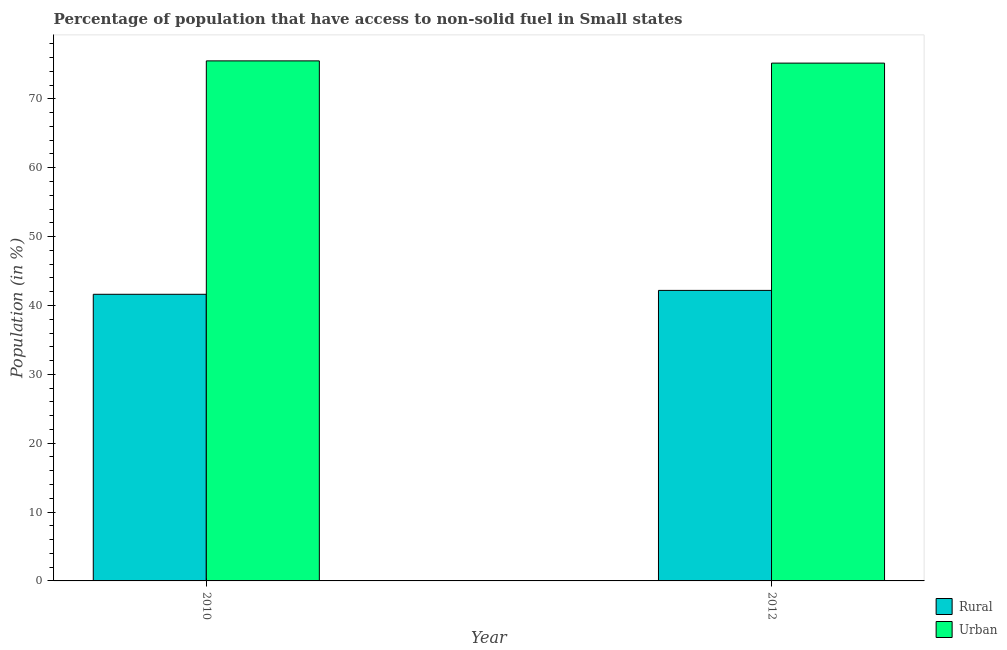How many different coloured bars are there?
Ensure brevity in your answer.  2. How many groups of bars are there?
Your response must be concise. 2. Are the number of bars on each tick of the X-axis equal?
Offer a very short reply. Yes. How many bars are there on the 2nd tick from the right?
Provide a succinct answer. 2. What is the label of the 2nd group of bars from the left?
Give a very brief answer. 2012. What is the rural population in 2010?
Your response must be concise. 41.62. Across all years, what is the maximum urban population?
Offer a very short reply. 75.52. Across all years, what is the minimum rural population?
Make the answer very short. 41.62. In which year was the rural population maximum?
Offer a terse response. 2012. In which year was the urban population minimum?
Provide a succinct answer. 2012. What is the total urban population in the graph?
Your answer should be compact. 150.72. What is the difference between the rural population in 2010 and that in 2012?
Give a very brief answer. -0.56. What is the difference between the urban population in 2012 and the rural population in 2010?
Make the answer very short. -0.33. What is the average rural population per year?
Make the answer very short. 41.91. What is the ratio of the urban population in 2010 to that in 2012?
Offer a terse response. 1. Is the urban population in 2010 less than that in 2012?
Make the answer very short. No. What does the 2nd bar from the left in 2012 represents?
Give a very brief answer. Urban. What does the 2nd bar from the right in 2012 represents?
Provide a succinct answer. Rural. Are all the bars in the graph horizontal?
Keep it short and to the point. No. How many years are there in the graph?
Make the answer very short. 2. Are the values on the major ticks of Y-axis written in scientific E-notation?
Ensure brevity in your answer.  No. Where does the legend appear in the graph?
Your response must be concise. Bottom right. How are the legend labels stacked?
Your answer should be compact. Vertical. What is the title of the graph?
Provide a short and direct response. Percentage of population that have access to non-solid fuel in Small states. Does "Forest land" appear as one of the legend labels in the graph?
Provide a short and direct response. No. What is the label or title of the X-axis?
Provide a succinct answer. Year. What is the Population (in %) in Rural in 2010?
Offer a very short reply. 41.62. What is the Population (in %) of Urban in 2010?
Your answer should be very brief. 75.52. What is the Population (in %) of Rural in 2012?
Ensure brevity in your answer.  42.19. What is the Population (in %) of Urban in 2012?
Offer a very short reply. 75.19. Across all years, what is the maximum Population (in %) in Rural?
Give a very brief answer. 42.19. Across all years, what is the maximum Population (in %) in Urban?
Your response must be concise. 75.52. Across all years, what is the minimum Population (in %) of Rural?
Offer a very short reply. 41.62. Across all years, what is the minimum Population (in %) of Urban?
Ensure brevity in your answer.  75.19. What is the total Population (in %) in Rural in the graph?
Your response must be concise. 83.81. What is the total Population (in %) in Urban in the graph?
Your answer should be compact. 150.72. What is the difference between the Population (in %) in Rural in 2010 and that in 2012?
Give a very brief answer. -0.56. What is the difference between the Population (in %) in Urban in 2010 and that in 2012?
Provide a short and direct response. 0.33. What is the difference between the Population (in %) of Rural in 2010 and the Population (in %) of Urban in 2012?
Keep it short and to the point. -33.57. What is the average Population (in %) in Rural per year?
Make the answer very short. 41.91. What is the average Population (in %) in Urban per year?
Your answer should be compact. 75.36. In the year 2010, what is the difference between the Population (in %) in Rural and Population (in %) in Urban?
Make the answer very short. -33.9. In the year 2012, what is the difference between the Population (in %) in Rural and Population (in %) in Urban?
Offer a terse response. -33.01. What is the ratio of the Population (in %) of Rural in 2010 to that in 2012?
Provide a succinct answer. 0.99. What is the difference between the highest and the second highest Population (in %) in Rural?
Your answer should be compact. 0.56. What is the difference between the highest and the second highest Population (in %) in Urban?
Your response must be concise. 0.33. What is the difference between the highest and the lowest Population (in %) in Rural?
Provide a short and direct response. 0.56. What is the difference between the highest and the lowest Population (in %) of Urban?
Give a very brief answer. 0.33. 